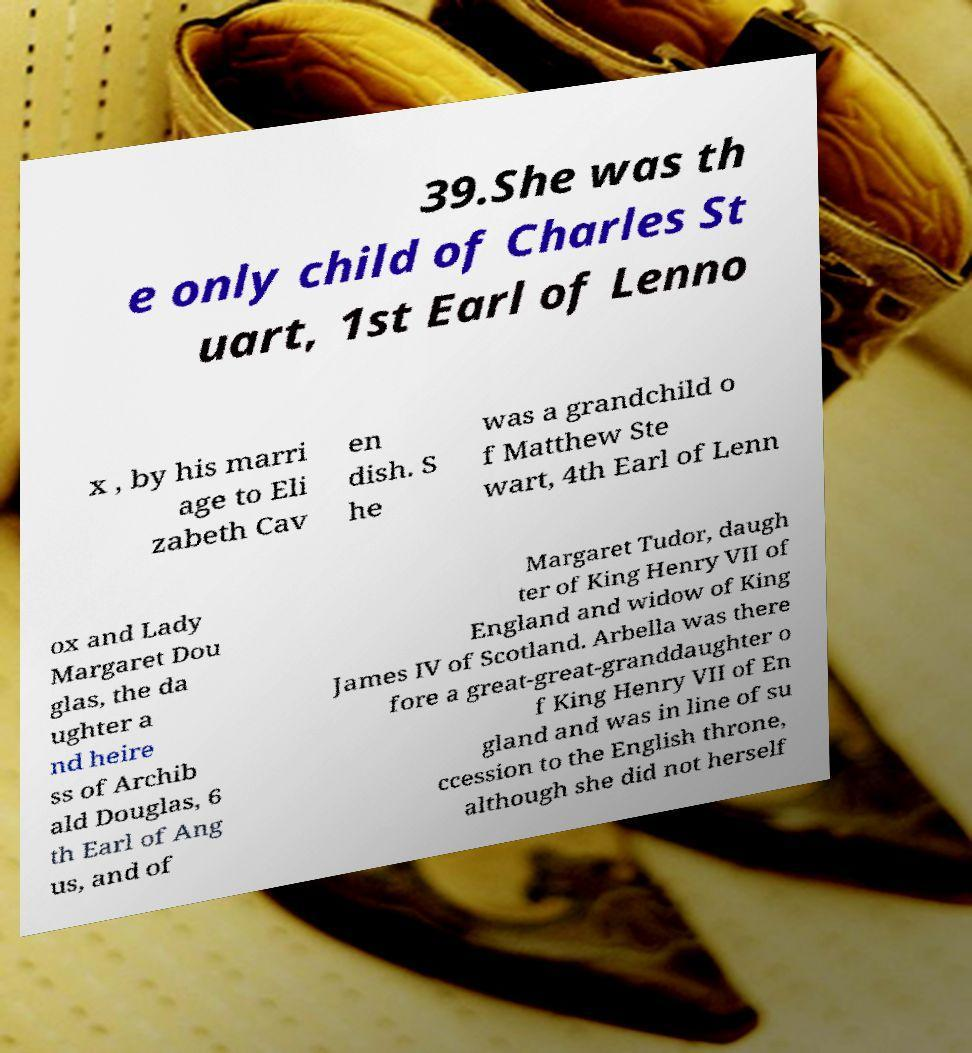Please read and relay the text visible in this image. What does it say? 39.She was th e only child of Charles St uart, 1st Earl of Lenno x , by his marri age to Eli zabeth Cav en dish. S he was a grandchild o f Matthew Ste wart, 4th Earl of Lenn ox and Lady Margaret Dou glas, the da ughter a nd heire ss of Archib ald Douglas, 6 th Earl of Ang us, and of Margaret Tudor, daugh ter of King Henry VII of England and widow of King James IV of Scotland. Arbella was there fore a great-great-granddaughter o f King Henry VII of En gland and was in line of su ccession to the English throne, although she did not herself 